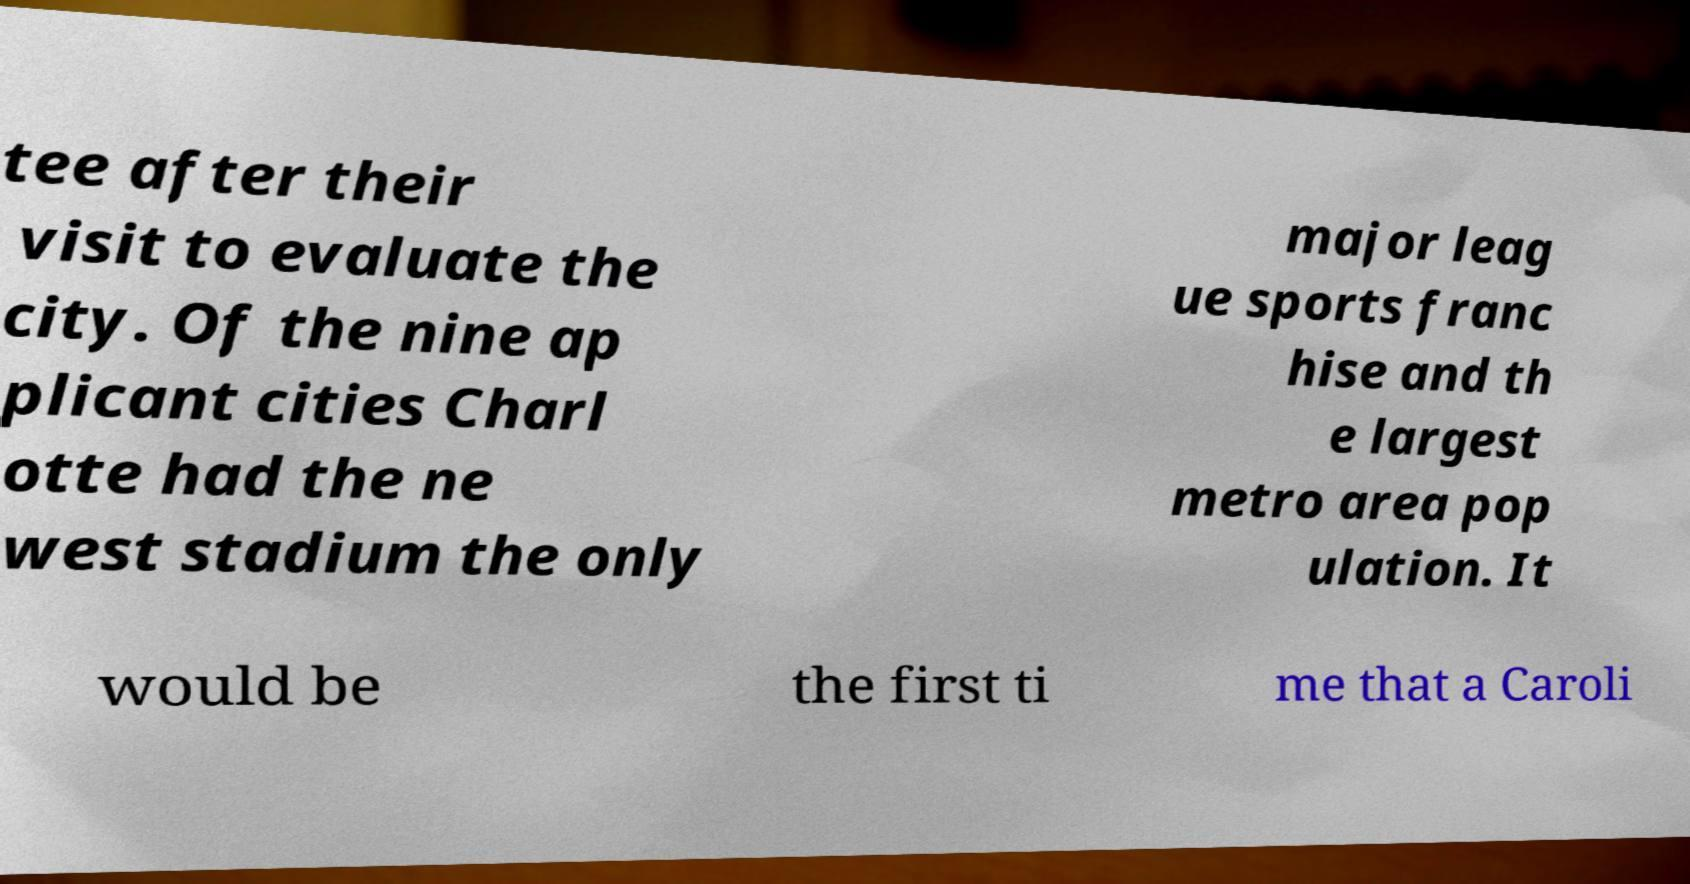For documentation purposes, I need the text within this image transcribed. Could you provide that? tee after their visit to evaluate the city. Of the nine ap plicant cities Charl otte had the ne west stadium the only major leag ue sports franc hise and th e largest metro area pop ulation. It would be the first ti me that a Caroli 